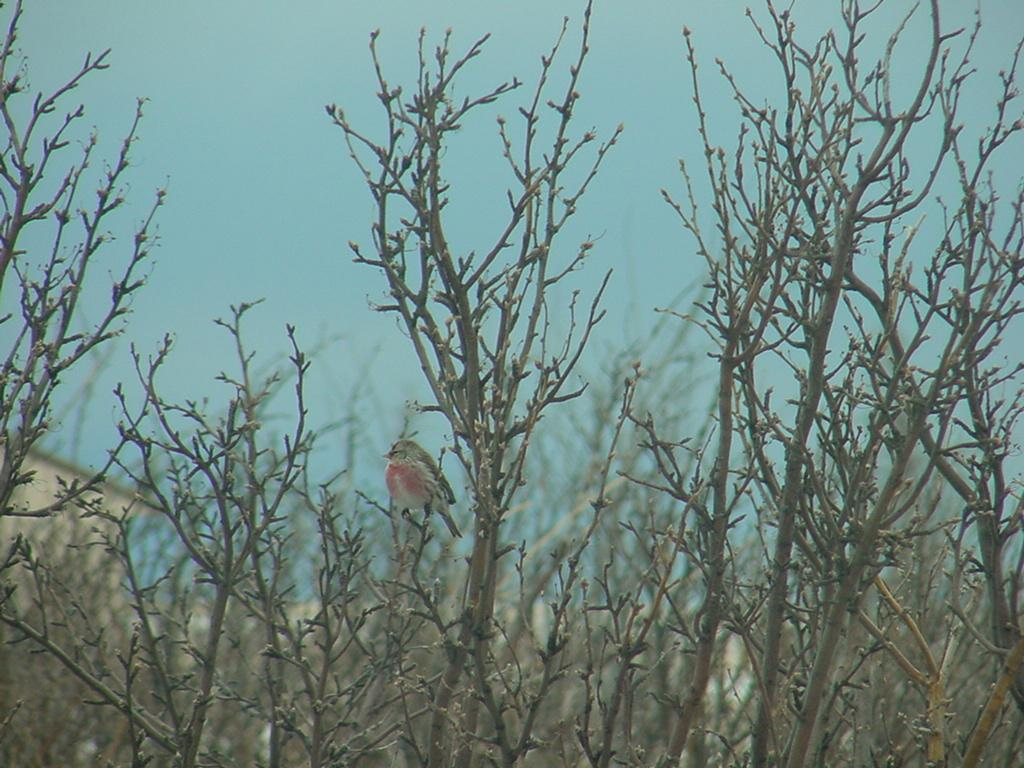What type of animal can be seen in the image? There is a bird in the image. What type of vegetation is present in the image? There are trees in the image. What structure is visible in the background of the image? There is a house in the background of the image. What part of the natural environment is visible in the image? The sky is visible in the background of the image. What else can be seen in the background of the image? There are other objects in the background of the image. What type of blood is visible on the bird's feathers in the image? There is no blood visible on the bird's feathers in the image. How many pies are present on the bird's back in the image? There are no pies present in the image, and the bird's back is not mentioned. 